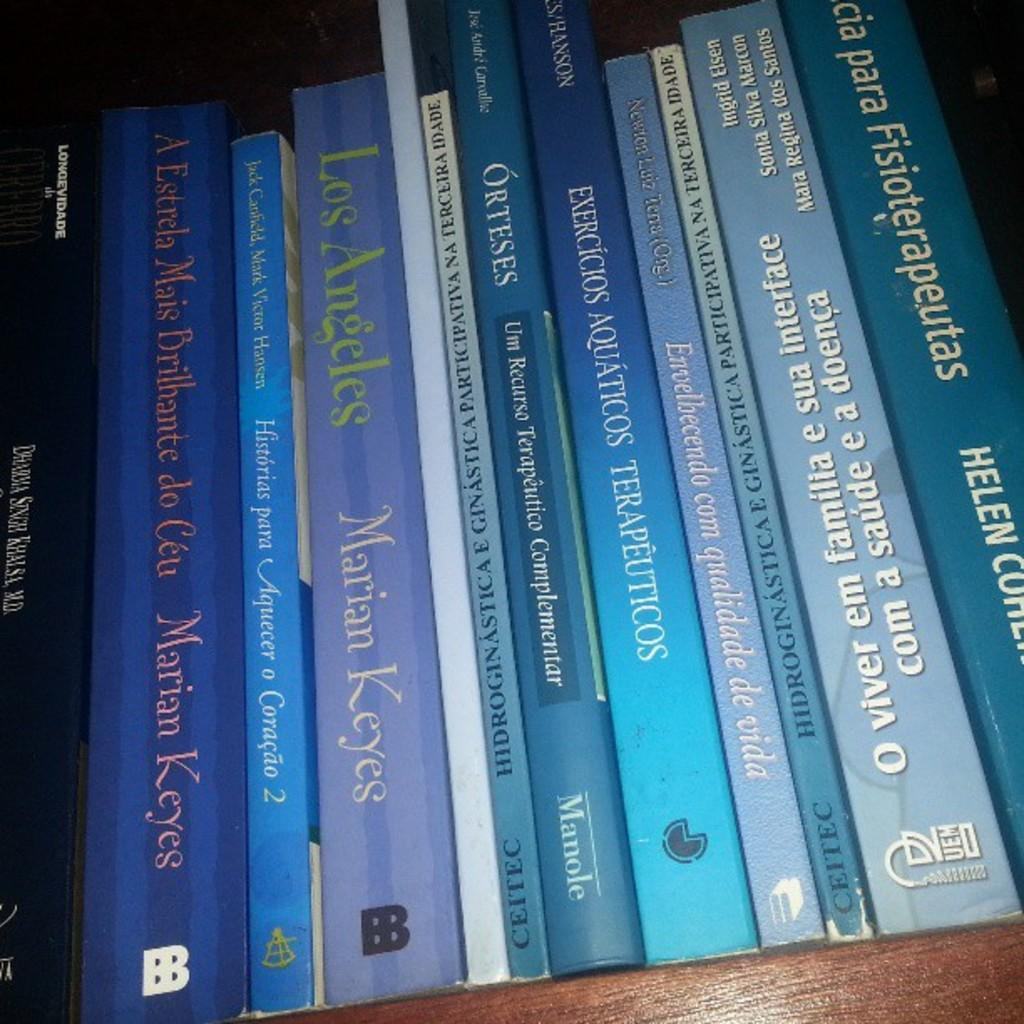<image>
Provide a brief description of the given image. A row of purple and blue books including one called Los Angeles by Marian Keyes. 